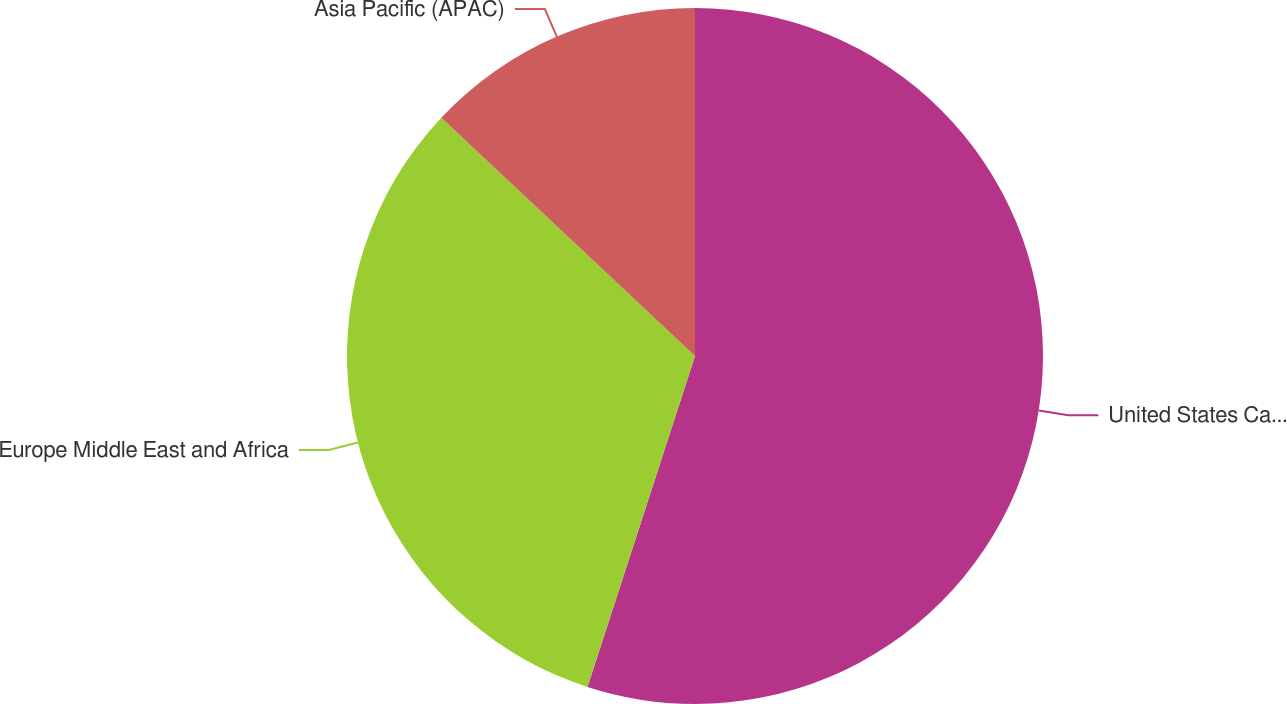Convert chart. <chart><loc_0><loc_0><loc_500><loc_500><pie_chart><fcel>United States Canada and Latin<fcel>Europe Middle East and Africa<fcel>Asia Pacific (APAC)<nl><fcel>55.0%<fcel>32.0%<fcel>13.0%<nl></chart> 